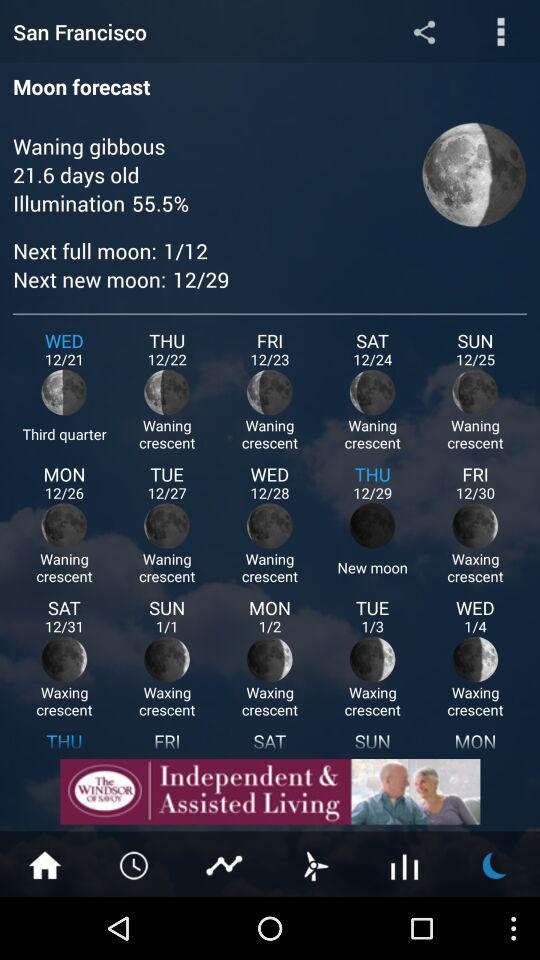What was the phase of the moon on 12/29? The phase of the moon was "New moon". 